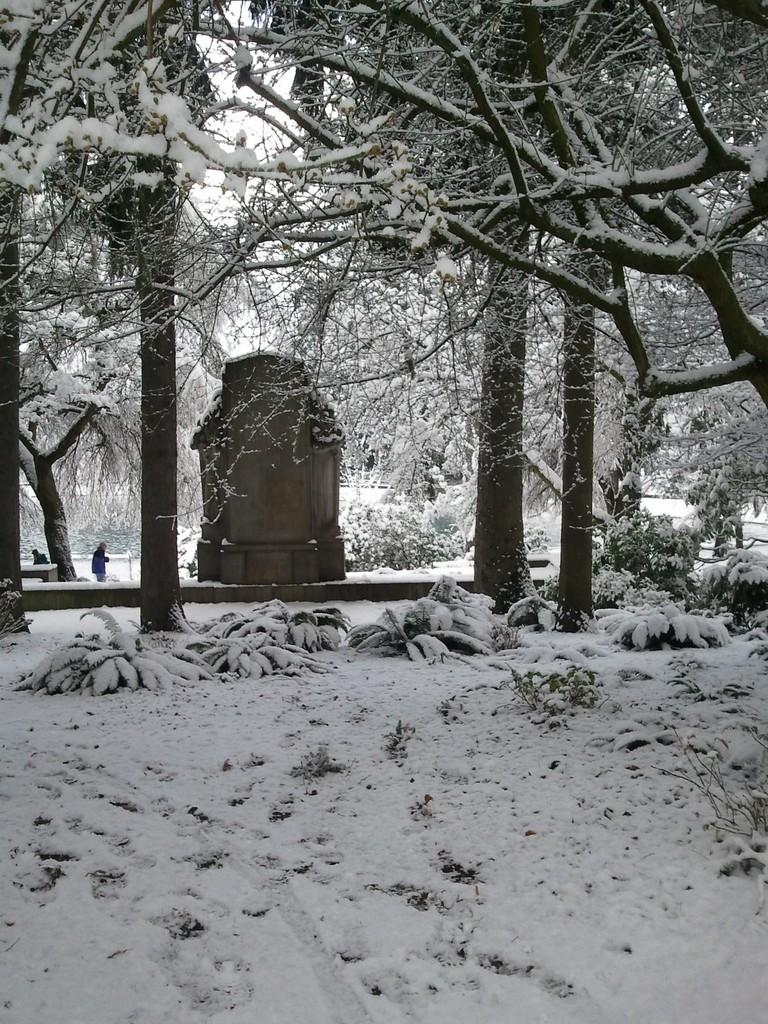What type of vegetation is present in the image? There are plants and trees in the image. What object made of wood can be seen in the image? There is a wooden box in the image. What is the condition of the people in the image? The people in the image are covered with snow. What type of recess can be seen in the image? There is no recess present in the image. What kind of note is attached to the wooden box in the image? There is no note attached to the wooden box in the image. 